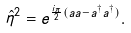<formula> <loc_0><loc_0><loc_500><loc_500>\hat { \eta } ^ { 2 } = e ^ { \frac { i \pi } { 2 } ( a a - a ^ { \dagger } a ^ { \dagger } ) } .</formula> 